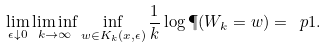<formula> <loc_0><loc_0><loc_500><loc_500>\lim _ { \epsilon \downarrow 0 } \liminf _ { k \rightarrow \infty } \inf _ { w \in K _ { k } ( x , \epsilon ) } \frac { 1 } { k } \log \P ( W _ { k } = w ) = \ p 1 .</formula> 